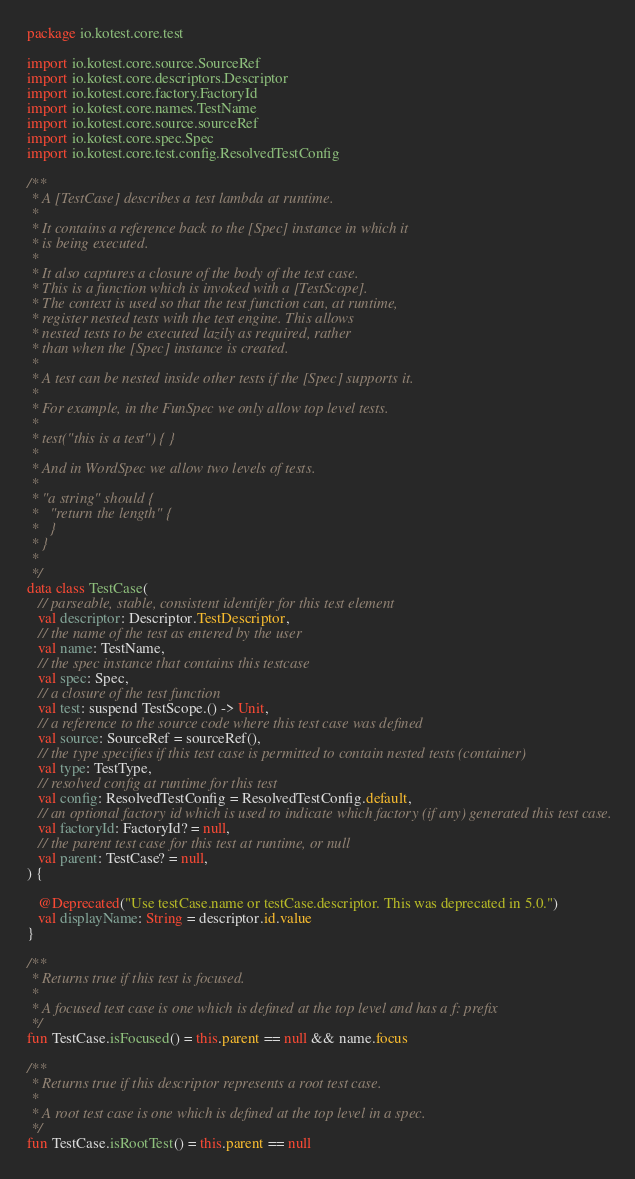Convert code to text. <code><loc_0><loc_0><loc_500><loc_500><_Kotlin_>package io.kotest.core.test

import io.kotest.core.source.SourceRef
import io.kotest.core.descriptors.Descriptor
import io.kotest.core.factory.FactoryId
import io.kotest.core.names.TestName
import io.kotest.core.source.sourceRef
import io.kotest.core.spec.Spec
import io.kotest.core.test.config.ResolvedTestConfig

/**
 * A [TestCase] describes a test lambda at runtime.
 *
 * It contains a reference back to the [Spec] instance in which it
 * is being executed.
 *
 * It also captures a closure of the body of the test case.
 * This is a function which is invoked with a [TestScope].
 * The context is used so that the test function can, at runtime,
 * register nested tests with the test engine. This allows
 * nested tests to be executed lazily as required, rather
 * than when the [Spec] instance is created.
 *
 * A test can be nested inside other tests if the [Spec] supports it.
 *
 * For example, in the FunSpec we only allow top level tests.
 *
 * test("this is a test") { }
 *
 * And in WordSpec we allow two levels of tests.
 *
 * "a string" should {
 *   "return the length" {
 *   }
 * }
 *
 */
data class TestCase(
   // parseable, stable, consistent identifer for this test element
   val descriptor: Descriptor.TestDescriptor,
   // the name of the test as entered by the user
   val name: TestName,
   // the spec instance that contains this testcase
   val spec: Spec,
   // a closure of the test function
   val test: suspend TestScope.() -> Unit,
   // a reference to the source code where this test case was defined
   val source: SourceRef = sourceRef(),
   // the type specifies if this test case is permitted to contain nested tests (container)
   val type: TestType,
   // resolved config at runtime for this test
   val config: ResolvedTestConfig = ResolvedTestConfig.default,
   // an optional factory id which is used to indicate which factory (if any) generated this test case.
   val factoryId: FactoryId? = null,
   // the parent test case for this test at runtime, or null
   val parent: TestCase? = null,
) {

   @Deprecated("Use testCase.name or testCase.descriptor. This was deprecated in 5.0.")
   val displayName: String = descriptor.id.value
}

/**
 * Returns true if this test is focused.
 *
 * A focused test case is one which is defined at the top level and has a f: prefix
 */
fun TestCase.isFocused() = this.parent == null && name.focus

/**
 * Returns true if this descriptor represents a root test case.
 *
 * A root test case is one which is defined at the top level in a spec.
 */
fun TestCase.isRootTest() = this.parent == null
</code> 